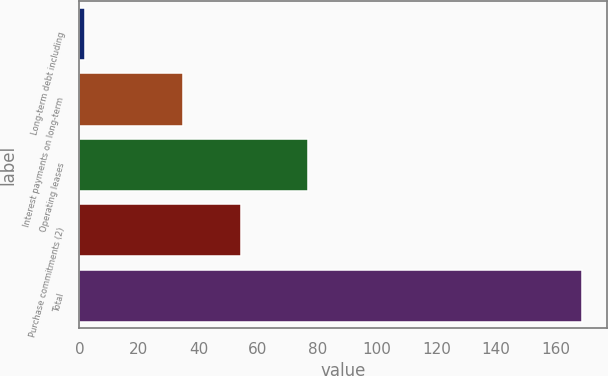Convert chart to OTSL. <chart><loc_0><loc_0><loc_500><loc_500><bar_chart><fcel>Long-term debt including<fcel>Interest payments on long-term<fcel>Operating leases<fcel>Purchase commitments (2)<fcel>Total<nl><fcel>1.9<fcel>34.7<fcel>76.7<fcel>54.4<fcel>168.7<nl></chart> 